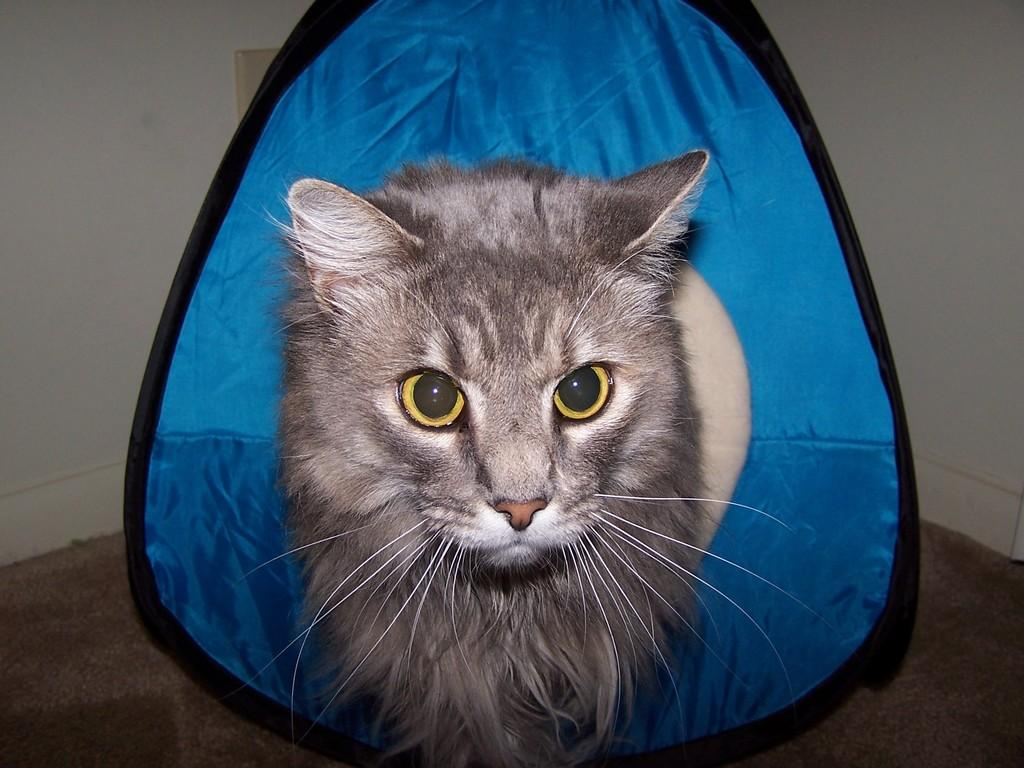What type of animal is present in the image? There is a cat in the image. Can you describe the background of the image? There is a blue color object in the background of the image. How many bats are flying around the cat in the image? There are no bats present in the image; it only features a cat and a blue color object in the background. 